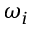Convert formula to latex. <formula><loc_0><loc_0><loc_500><loc_500>\omega _ { i }</formula> 